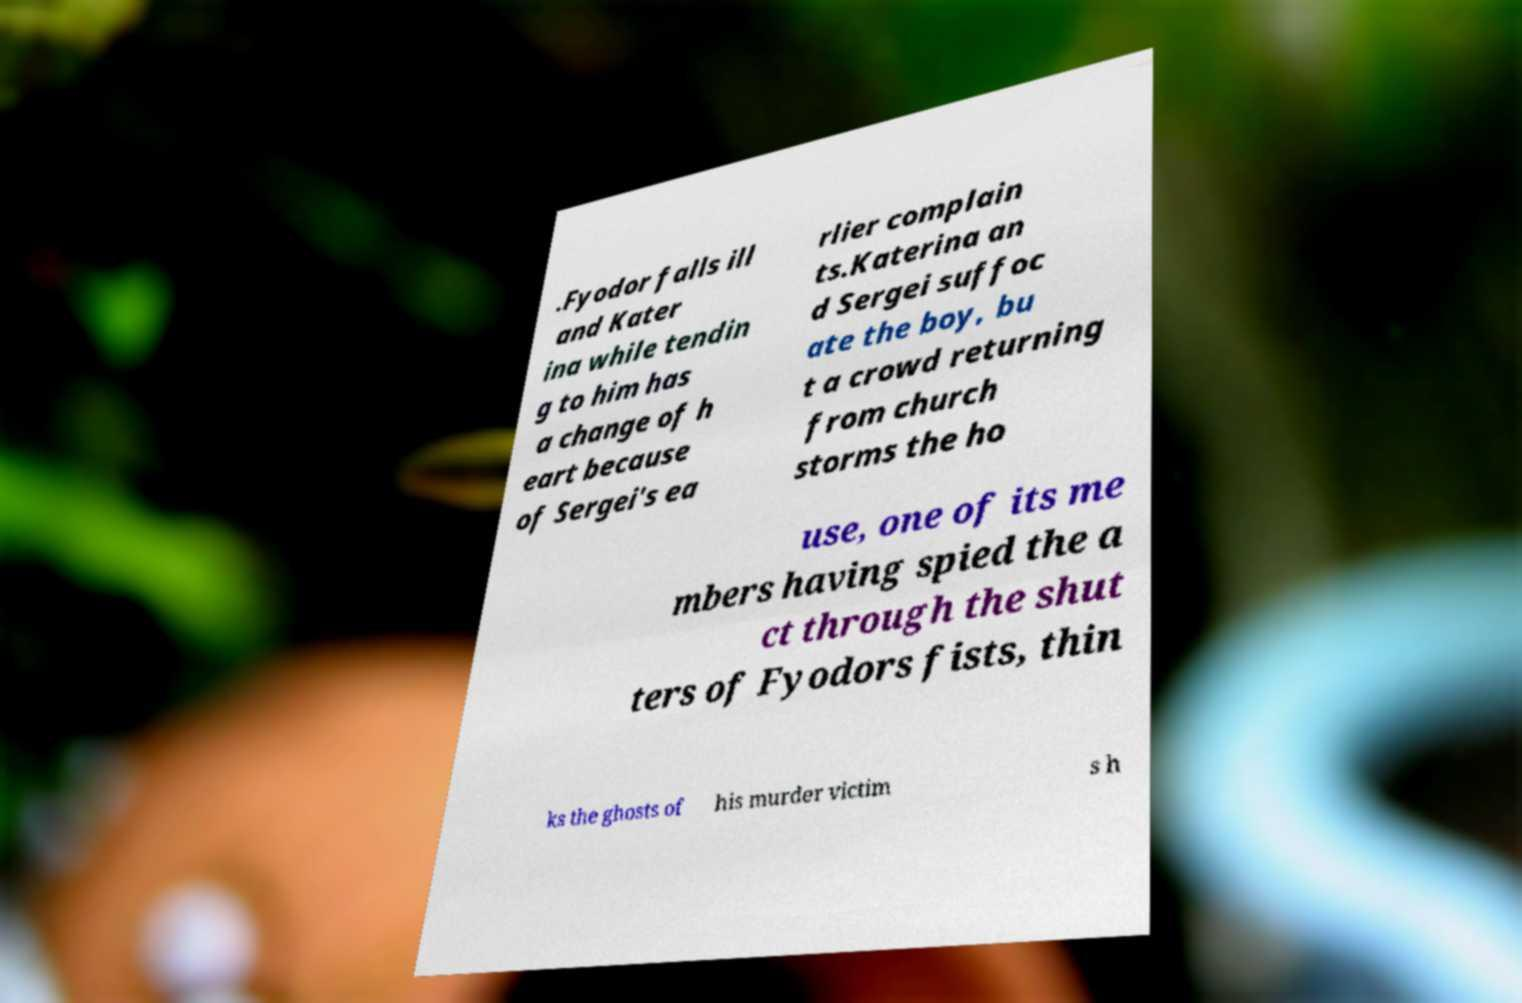I need the written content from this picture converted into text. Can you do that? .Fyodor falls ill and Kater ina while tendin g to him has a change of h eart because of Sergei's ea rlier complain ts.Katerina an d Sergei suffoc ate the boy, bu t a crowd returning from church storms the ho use, one of its me mbers having spied the a ct through the shut ters of Fyodors fists, thin ks the ghosts of his murder victim s h 